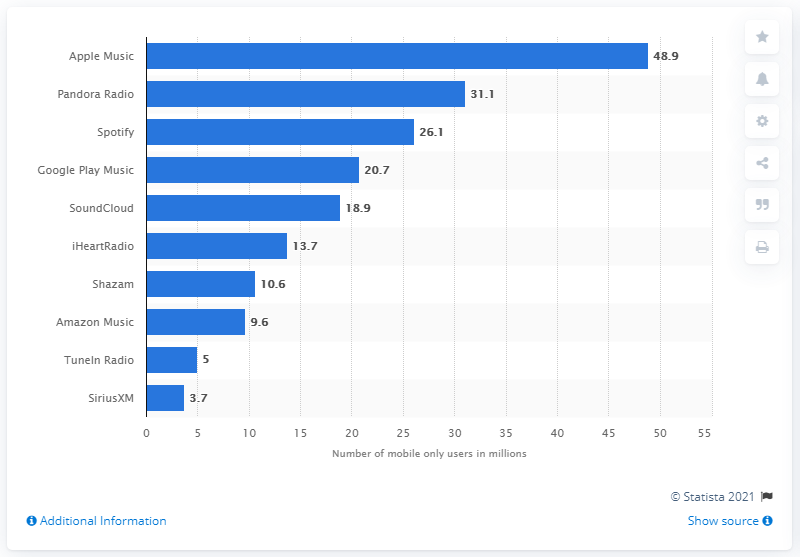Highlight a few significant elements in this photo. Apple Music had 48.9 million mobile users in March 2018. In March 2018, Apple Music was the most popular music streaming service. 